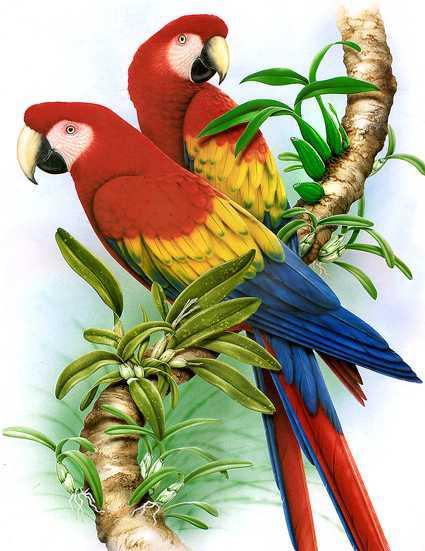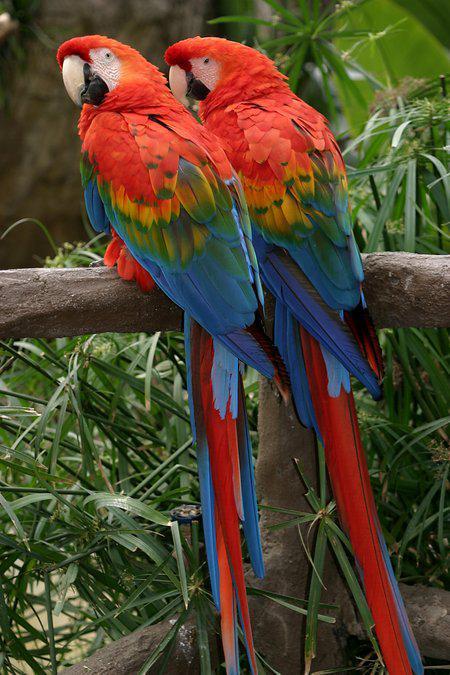The first image is the image on the left, the second image is the image on the right. Evaluate the accuracy of this statement regarding the images: "There are no more than 2 birds in each image.". Is it true? Answer yes or no. Yes. 